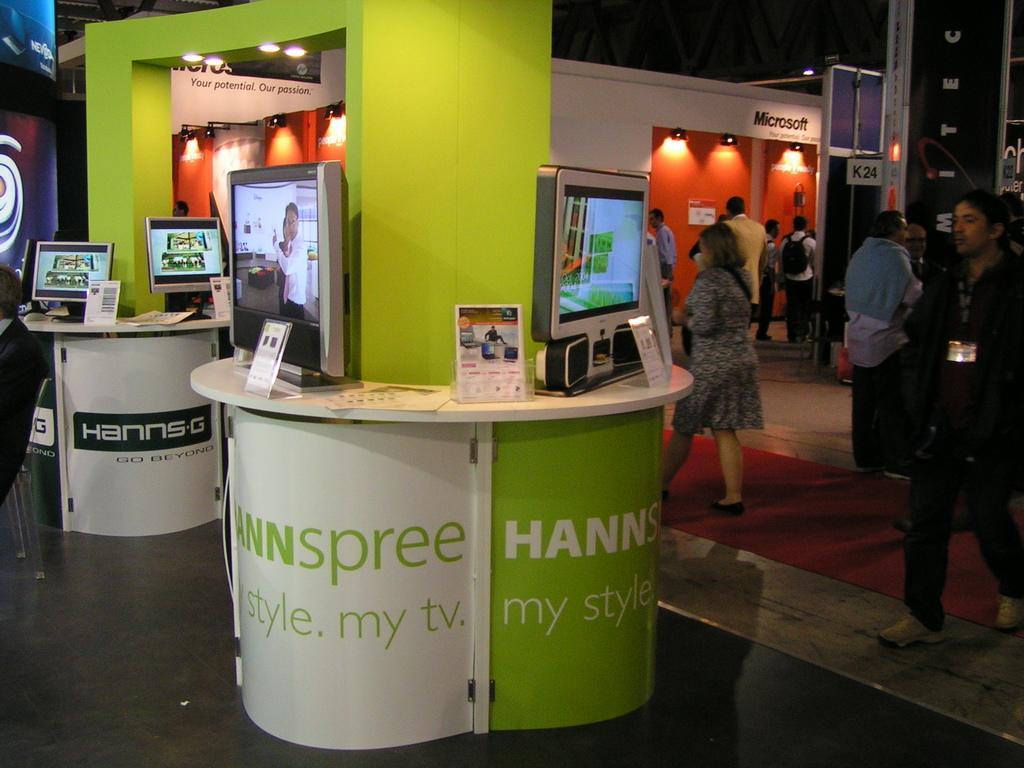In one or two sentences, can you explain what this image depicts? In this image we can see a few people, some of them are wearing a backpack, also we can see some monitors and posters on the table, there are some lights, posters with some texts written on it, also we can see the arch, and walls. 